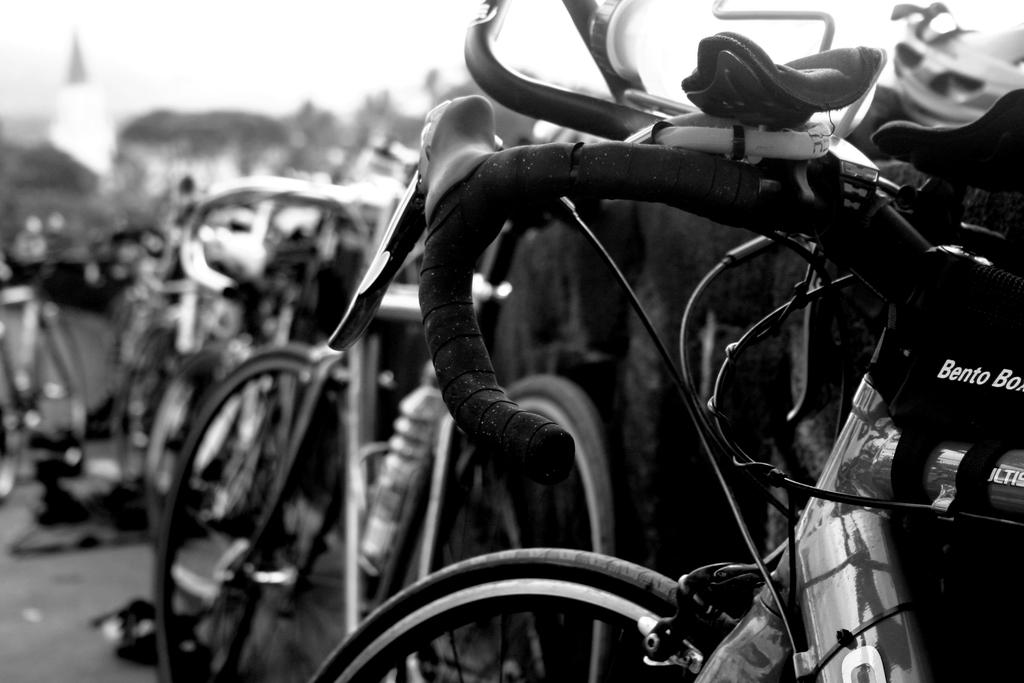What type of vehicles are parked on the side in the image? There are bicycles parked on the side in the image. What type of structure can be seen in the image? There is a house visible in the image. How would you describe the weather based on the image? The sky appears to be cloudy in the image. Can you identify any personal items in the image? There is a water bottle in a holder in the image. Where is the mailbox located in the image? There is no mailbox present in the image. What type of clothing is being washed in the image? There is no washing or clothing visible in the image. 